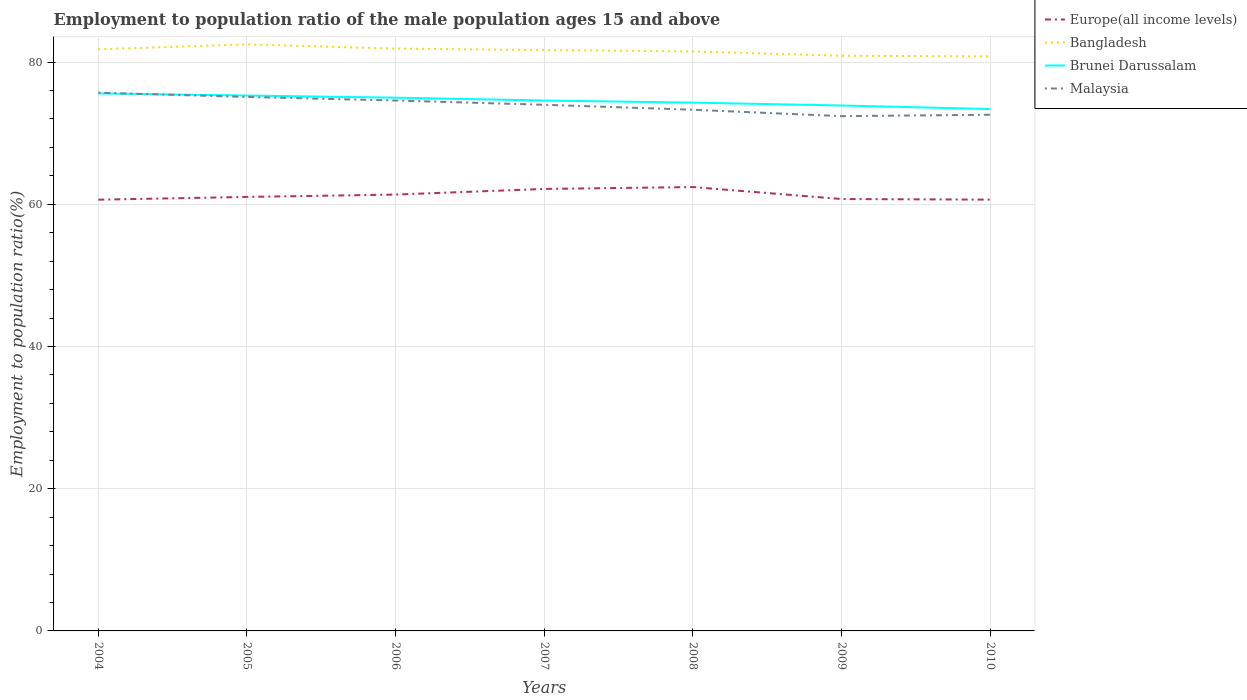Across all years, what is the maximum employment to population ratio in Bangladesh?
Give a very brief answer. 80.8. What is the total employment to population ratio in Malaysia in the graph?
Provide a succinct answer. 0.7. What is the difference between the highest and the second highest employment to population ratio in Malaysia?
Offer a very short reply. 3.3. Is the employment to population ratio in Brunei Darussalam strictly greater than the employment to population ratio in Bangladesh over the years?
Provide a short and direct response. Yes. How many years are there in the graph?
Provide a short and direct response. 7. Are the values on the major ticks of Y-axis written in scientific E-notation?
Offer a very short reply. No. Does the graph contain any zero values?
Provide a short and direct response. No. Does the graph contain grids?
Offer a terse response. Yes. Where does the legend appear in the graph?
Give a very brief answer. Top right. How many legend labels are there?
Your response must be concise. 4. How are the legend labels stacked?
Give a very brief answer. Vertical. What is the title of the graph?
Your response must be concise. Employment to population ratio of the male population ages 15 and above. What is the label or title of the X-axis?
Give a very brief answer. Years. What is the Employment to population ratio(%) of Europe(all income levels) in 2004?
Give a very brief answer. 60.65. What is the Employment to population ratio(%) in Bangladesh in 2004?
Ensure brevity in your answer.  81.8. What is the Employment to population ratio(%) in Brunei Darussalam in 2004?
Your response must be concise. 75.6. What is the Employment to population ratio(%) of Malaysia in 2004?
Offer a terse response. 75.7. What is the Employment to population ratio(%) of Europe(all income levels) in 2005?
Provide a short and direct response. 61.04. What is the Employment to population ratio(%) in Bangladesh in 2005?
Offer a very short reply. 82.5. What is the Employment to population ratio(%) of Brunei Darussalam in 2005?
Provide a short and direct response. 75.3. What is the Employment to population ratio(%) of Malaysia in 2005?
Offer a very short reply. 75.1. What is the Employment to population ratio(%) in Europe(all income levels) in 2006?
Your response must be concise. 61.37. What is the Employment to population ratio(%) of Bangladesh in 2006?
Ensure brevity in your answer.  81.9. What is the Employment to population ratio(%) in Malaysia in 2006?
Provide a short and direct response. 74.6. What is the Employment to population ratio(%) in Europe(all income levels) in 2007?
Ensure brevity in your answer.  62.16. What is the Employment to population ratio(%) of Bangladesh in 2007?
Your response must be concise. 81.7. What is the Employment to population ratio(%) in Brunei Darussalam in 2007?
Your response must be concise. 74.6. What is the Employment to population ratio(%) of Malaysia in 2007?
Keep it short and to the point. 74. What is the Employment to population ratio(%) in Europe(all income levels) in 2008?
Make the answer very short. 62.43. What is the Employment to population ratio(%) in Bangladesh in 2008?
Your answer should be compact. 81.5. What is the Employment to population ratio(%) of Brunei Darussalam in 2008?
Provide a succinct answer. 74.3. What is the Employment to population ratio(%) in Malaysia in 2008?
Offer a terse response. 73.3. What is the Employment to population ratio(%) in Europe(all income levels) in 2009?
Provide a short and direct response. 60.74. What is the Employment to population ratio(%) in Bangladesh in 2009?
Offer a terse response. 80.9. What is the Employment to population ratio(%) of Brunei Darussalam in 2009?
Ensure brevity in your answer.  73.9. What is the Employment to population ratio(%) of Malaysia in 2009?
Keep it short and to the point. 72.4. What is the Employment to population ratio(%) in Europe(all income levels) in 2010?
Provide a short and direct response. 60.66. What is the Employment to population ratio(%) of Bangladesh in 2010?
Your response must be concise. 80.8. What is the Employment to population ratio(%) in Brunei Darussalam in 2010?
Offer a terse response. 73.4. What is the Employment to population ratio(%) in Malaysia in 2010?
Keep it short and to the point. 72.6. Across all years, what is the maximum Employment to population ratio(%) in Europe(all income levels)?
Offer a very short reply. 62.43. Across all years, what is the maximum Employment to population ratio(%) of Bangladesh?
Your answer should be compact. 82.5. Across all years, what is the maximum Employment to population ratio(%) of Brunei Darussalam?
Provide a succinct answer. 75.6. Across all years, what is the maximum Employment to population ratio(%) of Malaysia?
Give a very brief answer. 75.7. Across all years, what is the minimum Employment to population ratio(%) of Europe(all income levels)?
Give a very brief answer. 60.65. Across all years, what is the minimum Employment to population ratio(%) in Bangladesh?
Give a very brief answer. 80.8. Across all years, what is the minimum Employment to population ratio(%) in Brunei Darussalam?
Provide a short and direct response. 73.4. Across all years, what is the minimum Employment to population ratio(%) of Malaysia?
Give a very brief answer. 72.4. What is the total Employment to population ratio(%) of Europe(all income levels) in the graph?
Keep it short and to the point. 429.06. What is the total Employment to population ratio(%) of Bangladesh in the graph?
Provide a short and direct response. 571.1. What is the total Employment to population ratio(%) in Brunei Darussalam in the graph?
Offer a terse response. 522.1. What is the total Employment to population ratio(%) of Malaysia in the graph?
Make the answer very short. 517.7. What is the difference between the Employment to population ratio(%) in Europe(all income levels) in 2004 and that in 2005?
Your answer should be very brief. -0.39. What is the difference between the Employment to population ratio(%) of Brunei Darussalam in 2004 and that in 2005?
Make the answer very short. 0.3. What is the difference between the Employment to population ratio(%) in Malaysia in 2004 and that in 2005?
Keep it short and to the point. 0.6. What is the difference between the Employment to population ratio(%) in Europe(all income levels) in 2004 and that in 2006?
Provide a succinct answer. -0.72. What is the difference between the Employment to population ratio(%) in Bangladesh in 2004 and that in 2006?
Keep it short and to the point. -0.1. What is the difference between the Employment to population ratio(%) in Brunei Darussalam in 2004 and that in 2006?
Offer a very short reply. 0.6. What is the difference between the Employment to population ratio(%) in Europe(all income levels) in 2004 and that in 2007?
Provide a succinct answer. -1.51. What is the difference between the Employment to population ratio(%) in Bangladesh in 2004 and that in 2007?
Your answer should be very brief. 0.1. What is the difference between the Employment to population ratio(%) of Europe(all income levels) in 2004 and that in 2008?
Ensure brevity in your answer.  -1.78. What is the difference between the Employment to population ratio(%) of Malaysia in 2004 and that in 2008?
Your answer should be compact. 2.4. What is the difference between the Employment to population ratio(%) in Europe(all income levels) in 2004 and that in 2009?
Offer a very short reply. -0.09. What is the difference between the Employment to population ratio(%) in Bangladesh in 2004 and that in 2009?
Your answer should be very brief. 0.9. What is the difference between the Employment to population ratio(%) in Europe(all income levels) in 2004 and that in 2010?
Ensure brevity in your answer.  -0.01. What is the difference between the Employment to population ratio(%) in Bangladesh in 2004 and that in 2010?
Ensure brevity in your answer.  1. What is the difference between the Employment to population ratio(%) of Brunei Darussalam in 2004 and that in 2010?
Make the answer very short. 2.2. What is the difference between the Employment to population ratio(%) of Malaysia in 2004 and that in 2010?
Keep it short and to the point. 3.1. What is the difference between the Employment to population ratio(%) in Europe(all income levels) in 2005 and that in 2006?
Ensure brevity in your answer.  -0.33. What is the difference between the Employment to population ratio(%) of Bangladesh in 2005 and that in 2006?
Make the answer very short. 0.6. What is the difference between the Employment to population ratio(%) of Europe(all income levels) in 2005 and that in 2007?
Your response must be concise. -1.13. What is the difference between the Employment to population ratio(%) of Europe(all income levels) in 2005 and that in 2008?
Ensure brevity in your answer.  -1.39. What is the difference between the Employment to population ratio(%) of Malaysia in 2005 and that in 2008?
Keep it short and to the point. 1.8. What is the difference between the Employment to population ratio(%) of Europe(all income levels) in 2005 and that in 2009?
Ensure brevity in your answer.  0.29. What is the difference between the Employment to population ratio(%) in Bangladesh in 2005 and that in 2009?
Give a very brief answer. 1.6. What is the difference between the Employment to population ratio(%) in Brunei Darussalam in 2005 and that in 2009?
Ensure brevity in your answer.  1.4. What is the difference between the Employment to population ratio(%) of Malaysia in 2005 and that in 2009?
Ensure brevity in your answer.  2.7. What is the difference between the Employment to population ratio(%) of Europe(all income levels) in 2005 and that in 2010?
Give a very brief answer. 0.38. What is the difference between the Employment to population ratio(%) of Brunei Darussalam in 2005 and that in 2010?
Your answer should be very brief. 1.9. What is the difference between the Employment to population ratio(%) in Malaysia in 2005 and that in 2010?
Keep it short and to the point. 2.5. What is the difference between the Employment to population ratio(%) in Europe(all income levels) in 2006 and that in 2007?
Your answer should be very brief. -0.79. What is the difference between the Employment to population ratio(%) in Brunei Darussalam in 2006 and that in 2007?
Provide a short and direct response. 0.4. What is the difference between the Employment to population ratio(%) of Malaysia in 2006 and that in 2007?
Offer a very short reply. 0.6. What is the difference between the Employment to population ratio(%) of Europe(all income levels) in 2006 and that in 2008?
Your answer should be very brief. -1.06. What is the difference between the Employment to population ratio(%) in Bangladesh in 2006 and that in 2008?
Give a very brief answer. 0.4. What is the difference between the Employment to population ratio(%) in Malaysia in 2006 and that in 2008?
Ensure brevity in your answer.  1.3. What is the difference between the Employment to population ratio(%) of Europe(all income levels) in 2006 and that in 2009?
Give a very brief answer. 0.63. What is the difference between the Employment to population ratio(%) of Europe(all income levels) in 2006 and that in 2010?
Offer a terse response. 0.71. What is the difference between the Employment to population ratio(%) in Brunei Darussalam in 2006 and that in 2010?
Your answer should be very brief. 1.6. What is the difference between the Employment to population ratio(%) of Malaysia in 2006 and that in 2010?
Offer a very short reply. 2. What is the difference between the Employment to population ratio(%) of Europe(all income levels) in 2007 and that in 2008?
Offer a terse response. -0.26. What is the difference between the Employment to population ratio(%) of Bangladesh in 2007 and that in 2008?
Give a very brief answer. 0.2. What is the difference between the Employment to population ratio(%) of Brunei Darussalam in 2007 and that in 2008?
Make the answer very short. 0.3. What is the difference between the Employment to population ratio(%) of Europe(all income levels) in 2007 and that in 2009?
Make the answer very short. 1.42. What is the difference between the Employment to population ratio(%) in Brunei Darussalam in 2007 and that in 2009?
Your answer should be compact. 0.7. What is the difference between the Employment to population ratio(%) in Malaysia in 2007 and that in 2009?
Your answer should be very brief. 1.6. What is the difference between the Employment to population ratio(%) of Europe(all income levels) in 2007 and that in 2010?
Keep it short and to the point. 1.5. What is the difference between the Employment to population ratio(%) in Brunei Darussalam in 2007 and that in 2010?
Your answer should be compact. 1.2. What is the difference between the Employment to population ratio(%) of Malaysia in 2007 and that in 2010?
Offer a very short reply. 1.4. What is the difference between the Employment to population ratio(%) of Europe(all income levels) in 2008 and that in 2009?
Keep it short and to the point. 1.69. What is the difference between the Employment to population ratio(%) of Malaysia in 2008 and that in 2009?
Keep it short and to the point. 0.9. What is the difference between the Employment to population ratio(%) in Europe(all income levels) in 2008 and that in 2010?
Provide a succinct answer. 1.77. What is the difference between the Employment to population ratio(%) of Bangladesh in 2008 and that in 2010?
Your response must be concise. 0.7. What is the difference between the Employment to population ratio(%) in Brunei Darussalam in 2008 and that in 2010?
Make the answer very short. 0.9. What is the difference between the Employment to population ratio(%) in Malaysia in 2008 and that in 2010?
Ensure brevity in your answer.  0.7. What is the difference between the Employment to population ratio(%) of Europe(all income levels) in 2009 and that in 2010?
Your answer should be very brief. 0.08. What is the difference between the Employment to population ratio(%) in Bangladesh in 2009 and that in 2010?
Your response must be concise. 0.1. What is the difference between the Employment to population ratio(%) of Brunei Darussalam in 2009 and that in 2010?
Your response must be concise. 0.5. What is the difference between the Employment to population ratio(%) in Malaysia in 2009 and that in 2010?
Your answer should be very brief. -0.2. What is the difference between the Employment to population ratio(%) of Europe(all income levels) in 2004 and the Employment to population ratio(%) of Bangladesh in 2005?
Offer a very short reply. -21.85. What is the difference between the Employment to population ratio(%) of Europe(all income levels) in 2004 and the Employment to population ratio(%) of Brunei Darussalam in 2005?
Give a very brief answer. -14.65. What is the difference between the Employment to population ratio(%) in Europe(all income levels) in 2004 and the Employment to population ratio(%) in Malaysia in 2005?
Your response must be concise. -14.45. What is the difference between the Employment to population ratio(%) in Bangladesh in 2004 and the Employment to population ratio(%) in Brunei Darussalam in 2005?
Offer a terse response. 6.5. What is the difference between the Employment to population ratio(%) of Europe(all income levels) in 2004 and the Employment to population ratio(%) of Bangladesh in 2006?
Make the answer very short. -21.25. What is the difference between the Employment to population ratio(%) in Europe(all income levels) in 2004 and the Employment to population ratio(%) in Brunei Darussalam in 2006?
Ensure brevity in your answer.  -14.35. What is the difference between the Employment to population ratio(%) of Europe(all income levels) in 2004 and the Employment to population ratio(%) of Malaysia in 2006?
Your answer should be very brief. -13.95. What is the difference between the Employment to population ratio(%) of Brunei Darussalam in 2004 and the Employment to population ratio(%) of Malaysia in 2006?
Make the answer very short. 1. What is the difference between the Employment to population ratio(%) in Europe(all income levels) in 2004 and the Employment to population ratio(%) in Bangladesh in 2007?
Your response must be concise. -21.05. What is the difference between the Employment to population ratio(%) in Europe(all income levels) in 2004 and the Employment to population ratio(%) in Brunei Darussalam in 2007?
Ensure brevity in your answer.  -13.95. What is the difference between the Employment to population ratio(%) in Europe(all income levels) in 2004 and the Employment to population ratio(%) in Malaysia in 2007?
Your answer should be very brief. -13.35. What is the difference between the Employment to population ratio(%) of Bangladesh in 2004 and the Employment to population ratio(%) of Malaysia in 2007?
Your answer should be very brief. 7.8. What is the difference between the Employment to population ratio(%) in Europe(all income levels) in 2004 and the Employment to population ratio(%) in Bangladesh in 2008?
Your answer should be compact. -20.85. What is the difference between the Employment to population ratio(%) in Europe(all income levels) in 2004 and the Employment to population ratio(%) in Brunei Darussalam in 2008?
Give a very brief answer. -13.65. What is the difference between the Employment to population ratio(%) in Europe(all income levels) in 2004 and the Employment to population ratio(%) in Malaysia in 2008?
Give a very brief answer. -12.65. What is the difference between the Employment to population ratio(%) in Bangladesh in 2004 and the Employment to population ratio(%) in Malaysia in 2008?
Your response must be concise. 8.5. What is the difference between the Employment to population ratio(%) of Brunei Darussalam in 2004 and the Employment to population ratio(%) of Malaysia in 2008?
Give a very brief answer. 2.3. What is the difference between the Employment to population ratio(%) in Europe(all income levels) in 2004 and the Employment to population ratio(%) in Bangladesh in 2009?
Your response must be concise. -20.25. What is the difference between the Employment to population ratio(%) of Europe(all income levels) in 2004 and the Employment to population ratio(%) of Brunei Darussalam in 2009?
Make the answer very short. -13.25. What is the difference between the Employment to population ratio(%) in Europe(all income levels) in 2004 and the Employment to population ratio(%) in Malaysia in 2009?
Offer a very short reply. -11.75. What is the difference between the Employment to population ratio(%) of Bangladesh in 2004 and the Employment to population ratio(%) of Brunei Darussalam in 2009?
Your answer should be compact. 7.9. What is the difference between the Employment to population ratio(%) of Bangladesh in 2004 and the Employment to population ratio(%) of Malaysia in 2009?
Make the answer very short. 9.4. What is the difference between the Employment to population ratio(%) in Europe(all income levels) in 2004 and the Employment to population ratio(%) in Bangladesh in 2010?
Your answer should be compact. -20.15. What is the difference between the Employment to population ratio(%) of Europe(all income levels) in 2004 and the Employment to population ratio(%) of Brunei Darussalam in 2010?
Provide a short and direct response. -12.75. What is the difference between the Employment to population ratio(%) of Europe(all income levels) in 2004 and the Employment to population ratio(%) of Malaysia in 2010?
Your answer should be compact. -11.95. What is the difference between the Employment to population ratio(%) of Brunei Darussalam in 2004 and the Employment to population ratio(%) of Malaysia in 2010?
Make the answer very short. 3. What is the difference between the Employment to population ratio(%) in Europe(all income levels) in 2005 and the Employment to population ratio(%) in Bangladesh in 2006?
Keep it short and to the point. -20.86. What is the difference between the Employment to population ratio(%) in Europe(all income levels) in 2005 and the Employment to population ratio(%) in Brunei Darussalam in 2006?
Your answer should be very brief. -13.96. What is the difference between the Employment to population ratio(%) in Europe(all income levels) in 2005 and the Employment to population ratio(%) in Malaysia in 2006?
Offer a terse response. -13.56. What is the difference between the Employment to population ratio(%) in Bangladesh in 2005 and the Employment to population ratio(%) in Malaysia in 2006?
Provide a short and direct response. 7.9. What is the difference between the Employment to population ratio(%) in Brunei Darussalam in 2005 and the Employment to population ratio(%) in Malaysia in 2006?
Ensure brevity in your answer.  0.7. What is the difference between the Employment to population ratio(%) in Europe(all income levels) in 2005 and the Employment to population ratio(%) in Bangladesh in 2007?
Keep it short and to the point. -20.66. What is the difference between the Employment to population ratio(%) in Europe(all income levels) in 2005 and the Employment to population ratio(%) in Brunei Darussalam in 2007?
Your response must be concise. -13.56. What is the difference between the Employment to population ratio(%) in Europe(all income levels) in 2005 and the Employment to population ratio(%) in Malaysia in 2007?
Offer a terse response. -12.96. What is the difference between the Employment to population ratio(%) in Brunei Darussalam in 2005 and the Employment to population ratio(%) in Malaysia in 2007?
Offer a terse response. 1.3. What is the difference between the Employment to population ratio(%) of Europe(all income levels) in 2005 and the Employment to population ratio(%) of Bangladesh in 2008?
Your answer should be compact. -20.46. What is the difference between the Employment to population ratio(%) of Europe(all income levels) in 2005 and the Employment to population ratio(%) of Brunei Darussalam in 2008?
Give a very brief answer. -13.26. What is the difference between the Employment to population ratio(%) in Europe(all income levels) in 2005 and the Employment to population ratio(%) in Malaysia in 2008?
Your response must be concise. -12.26. What is the difference between the Employment to population ratio(%) in Bangladesh in 2005 and the Employment to population ratio(%) in Malaysia in 2008?
Your answer should be compact. 9.2. What is the difference between the Employment to population ratio(%) in Brunei Darussalam in 2005 and the Employment to population ratio(%) in Malaysia in 2008?
Ensure brevity in your answer.  2. What is the difference between the Employment to population ratio(%) in Europe(all income levels) in 2005 and the Employment to population ratio(%) in Bangladesh in 2009?
Your answer should be compact. -19.86. What is the difference between the Employment to population ratio(%) in Europe(all income levels) in 2005 and the Employment to population ratio(%) in Brunei Darussalam in 2009?
Give a very brief answer. -12.86. What is the difference between the Employment to population ratio(%) in Europe(all income levels) in 2005 and the Employment to population ratio(%) in Malaysia in 2009?
Provide a short and direct response. -11.36. What is the difference between the Employment to population ratio(%) in Bangladesh in 2005 and the Employment to population ratio(%) in Brunei Darussalam in 2009?
Your answer should be compact. 8.6. What is the difference between the Employment to population ratio(%) of Bangladesh in 2005 and the Employment to population ratio(%) of Malaysia in 2009?
Your response must be concise. 10.1. What is the difference between the Employment to population ratio(%) in Brunei Darussalam in 2005 and the Employment to population ratio(%) in Malaysia in 2009?
Your answer should be compact. 2.9. What is the difference between the Employment to population ratio(%) of Europe(all income levels) in 2005 and the Employment to population ratio(%) of Bangladesh in 2010?
Make the answer very short. -19.76. What is the difference between the Employment to population ratio(%) in Europe(all income levels) in 2005 and the Employment to population ratio(%) in Brunei Darussalam in 2010?
Keep it short and to the point. -12.36. What is the difference between the Employment to population ratio(%) in Europe(all income levels) in 2005 and the Employment to population ratio(%) in Malaysia in 2010?
Your answer should be compact. -11.56. What is the difference between the Employment to population ratio(%) in Bangladesh in 2005 and the Employment to population ratio(%) in Malaysia in 2010?
Ensure brevity in your answer.  9.9. What is the difference between the Employment to population ratio(%) of Europe(all income levels) in 2006 and the Employment to population ratio(%) of Bangladesh in 2007?
Make the answer very short. -20.33. What is the difference between the Employment to population ratio(%) of Europe(all income levels) in 2006 and the Employment to population ratio(%) of Brunei Darussalam in 2007?
Give a very brief answer. -13.23. What is the difference between the Employment to population ratio(%) of Europe(all income levels) in 2006 and the Employment to population ratio(%) of Malaysia in 2007?
Your answer should be compact. -12.63. What is the difference between the Employment to population ratio(%) in Bangladesh in 2006 and the Employment to population ratio(%) in Brunei Darussalam in 2007?
Ensure brevity in your answer.  7.3. What is the difference between the Employment to population ratio(%) in Bangladesh in 2006 and the Employment to population ratio(%) in Malaysia in 2007?
Your answer should be compact. 7.9. What is the difference between the Employment to population ratio(%) of Europe(all income levels) in 2006 and the Employment to population ratio(%) of Bangladesh in 2008?
Your response must be concise. -20.13. What is the difference between the Employment to population ratio(%) in Europe(all income levels) in 2006 and the Employment to population ratio(%) in Brunei Darussalam in 2008?
Your answer should be very brief. -12.93. What is the difference between the Employment to population ratio(%) in Europe(all income levels) in 2006 and the Employment to population ratio(%) in Malaysia in 2008?
Give a very brief answer. -11.93. What is the difference between the Employment to population ratio(%) of Bangladesh in 2006 and the Employment to population ratio(%) of Malaysia in 2008?
Offer a terse response. 8.6. What is the difference between the Employment to population ratio(%) in Europe(all income levels) in 2006 and the Employment to population ratio(%) in Bangladesh in 2009?
Keep it short and to the point. -19.53. What is the difference between the Employment to population ratio(%) of Europe(all income levels) in 2006 and the Employment to population ratio(%) of Brunei Darussalam in 2009?
Keep it short and to the point. -12.53. What is the difference between the Employment to population ratio(%) in Europe(all income levels) in 2006 and the Employment to population ratio(%) in Malaysia in 2009?
Provide a short and direct response. -11.03. What is the difference between the Employment to population ratio(%) of Bangladesh in 2006 and the Employment to population ratio(%) of Malaysia in 2009?
Give a very brief answer. 9.5. What is the difference between the Employment to population ratio(%) in Brunei Darussalam in 2006 and the Employment to population ratio(%) in Malaysia in 2009?
Provide a succinct answer. 2.6. What is the difference between the Employment to population ratio(%) of Europe(all income levels) in 2006 and the Employment to population ratio(%) of Bangladesh in 2010?
Your answer should be compact. -19.43. What is the difference between the Employment to population ratio(%) in Europe(all income levels) in 2006 and the Employment to population ratio(%) in Brunei Darussalam in 2010?
Your response must be concise. -12.03. What is the difference between the Employment to population ratio(%) in Europe(all income levels) in 2006 and the Employment to population ratio(%) in Malaysia in 2010?
Provide a short and direct response. -11.23. What is the difference between the Employment to population ratio(%) in Bangladesh in 2006 and the Employment to population ratio(%) in Brunei Darussalam in 2010?
Offer a very short reply. 8.5. What is the difference between the Employment to population ratio(%) in Brunei Darussalam in 2006 and the Employment to population ratio(%) in Malaysia in 2010?
Keep it short and to the point. 2.4. What is the difference between the Employment to population ratio(%) in Europe(all income levels) in 2007 and the Employment to population ratio(%) in Bangladesh in 2008?
Offer a very short reply. -19.34. What is the difference between the Employment to population ratio(%) in Europe(all income levels) in 2007 and the Employment to population ratio(%) in Brunei Darussalam in 2008?
Ensure brevity in your answer.  -12.14. What is the difference between the Employment to population ratio(%) of Europe(all income levels) in 2007 and the Employment to population ratio(%) of Malaysia in 2008?
Provide a short and direct response. -11.14. What is the difference between the Employment to population ratio(%) of Europe(all income levels) in 2007 and the Employment to population ratio(%) of Bangladesh in 2009?
Your answer should be very brief. -18.74. What is the difference between the Employment to population ratio(%) of Europe(all income levels) in 2007 and the Employment to population ratio(%) of Brunei Darussalam in 2009?
Provide a succinct answer. -11.74. What is the difference between the Employment to population ratio(%) of Europe(all income levels) in 2007 and the Employment to population ratio(%) of Malaysia in 2009?
Provide a succinct answer. -10.24. What is the difference between the Employment to population ratio(%) of Bangladesh in 2007 and the Employment to population ratio(%) of Malaysia in 2009?
Offer a very short reply. 9.3. What is the difference between the Employment to population ratio(%) of Europe(all income levels) in 2007 and the Employment to population ratio(%) of Bangladesh in 2010?
Keep it short and to the point. -18.64. What is the difference between the Employment to population ratio(%) in Europe(all income levels) in 2007 and the Employment to population ratio(%) in Brunei Darussalam in 2010?
Give a very brief answer. -11.24. What is the difference between the Employment to population ratio(%) in Europe(all income levels) in 2007 and the Employment to population ratio(%) in Malaysia in 2010?
Provide a succinct answer. -10.44. What is the difference between the Employment to population ratio(%) of Bangladesh in 2007 and the Employment to population ratio(%) of Brunei Darussalam in 2010?
Give a very brief answer. 8.3. What is the difference between the Employment to population ratio(%) of Brunei Darussalam in 2007 and the Employment to population ratio(%) of Malaysia in 2010?
Keep it short and to the point. 2. What is the difference between the Employment to population ratio(%) in Europe(all income levels) in 2008 and the Employment to population ratio(%) in Bangladesh in 2009?
Offer a very short reply. -18.47. What is the difference between the Employment to population ratio(%) in Europe(all income levels) in 2008 and the Employment to population ratio(%) in Brunei Darussalam in 2009?
Provide a succinct answer. -11.47. What is the difference between the Employment to population ratio(%) in Europe(all income levels) in 2008 and the Employment to population ratio(%) in Malaysia in 2009?
Ensure brevity in your answer.  -9.97. What is the difference between the Employment to population ratio(%) of Bangladesh in 2008 and the Employment to population ratio(%) of Brunei Darussalam in 2009?
Your answer should be very brief. 7.6. What is the difference between the Employment to population ratio(%) of Bangladesh in 2008 and the Employment to population ratio(%) of Malaysia in 2009?
Give a very brief answer. 9.1. What is the difference between the Employment to population ratio(%) in Brunei Darussalam in 2008 and the Employment to population ratio(%) in Malaysia in 2009?
Your response must be concise. 1.9. What is the difference between the Employment to population ratio(%) of Europe(all income levels) in 2008 and the Employment to population ratio(%) of Bangladesh in 2010?
Your response must be concise. -18.37. What is the difference between the Employment to population ratio(%) of Europe(all income levels) in 2008 and the Employment to population ratio(%) of Brunei Darussalam in 2010?
Provide a short and direct response. -10.97. What is the difference between the Employment to population ratio(%) of Europe(all income levels) in 2008 and the Employment to population ratio(%) of Malaysia in 2010?
Keep it short and to the point. -10.17. What is the difference between the Employment to population ratio(%) in Bangladesh in 2008 and the Employment to population ratio(%) in Brunei Darussalam in 2010?
Keep it short and to the point. 8.1. What is the difference between the Employment to population ratio(%) of Europe(all income levels) in 2009 and the Employment to population ratio(%) of Bangladesh in 2010?
Your answer should be very brief. -20.06. What is the difference between the Employment to population ratio(%) in Europe(all income levels) in 2009 and the Employment to population ratio(%) in Brunei Darussalam in 2010?
Give a very brief answer. -12.66. What is the difference between the Employment to population ratio(%) of Europe(all income levels) in 2009 and the Employment to population ratio(%) of Malaysia in 2010?
Your response must be concise. -11.86. What is the difference between the Employment to population ratio(%) of Bangladesh in 2009 and the Employment to population ratio(%) of Brunei Darussalam in 2010?
Your answer should be compact. 7.5. What is the difference between the Employment to population ratio(%) of Bangladesh in 2009 and the Employment to population ratio(%) of Malaysia in 2010?
Your answer should be compact. 8.3. What is the average Employment to population ratio(%) in Europe(all income levels) per year?
Your answer should be very brief. 61.29. What is the average Employment to population ratio(%) in Bangladesh per year?
Your answer should be compact. 81.59. What is the average Employment to population ratio(%) in Brunei Darussalam per year?
Offer a very short reply. 74.59. What is the average Employment to population ratio(%) in Malaysia per year?
Keep it short and to the point. 73.96. In the year 2004, what is the difference between the Employment to population ratio(%) in Europe(all income levels) and Employment to population ratio(%) in Bangladesh?
Offer a very short reply. -21.15. In the year 2004, what is the difference between the Employment to population ratio(%) in Europe(all income levels) and Employment to population ratio(%) in Brunei Darussalam?
Ensure brevity in your answer.  -14.95. In the year 2004, what is the difference between the Employment to population ratio(%) of Europe(all income levels) and Employment to population ratio(%) of Malaysia?
Offer a very short reply. -15.05. In the year 2004, what is the difference between the Employment to population ratio(%) in Bangladesh and Employment to population ratio(%) in Brunei Darussalam?
Give a very brief answer. 6.2. In the year 2004, what is the difference between the Employment to population ratio(%) in Bangladesh and Employment to population ratio(%) in Malaysia?
Make the answer very short. 6.1. In the year 2005, what is the difference between the Employment to population ratio(%) in Europe(all income levels) and Employment to population ratio(%) in Bangladesh?
Your answer should be very brief. -21.46. In the year 2005, what is the difference between the Employment to population ratio(%) in Europe(all income levels) and Employment to population ratio(%) in Brunei Darussalam?
Offer a very short reply. -14.26. In the year 2005, what is the difference between the Employment to population ratio(%) of Europe(all income levels) and Employment to population ratio(%) of Malaysia?
Your answer should be compact. -14.06. In the year 2005, what is the difference between the Employment to population ratio(%) in Bangladesh and Employment to population ratio(%) in Malaysia?
Give a very brief answer. 7.4. In the year 2006, what is the difference between the Employment to population ratio(%) in Europe(all income levels) and Employment to population ratio(%) in Bangladesh?
Offer a terse response. -20.53. In the year 2006, what is the difference between the Employment to population ratio(%) in Europe(all income levels) and Employment to population ratio(%) in Brunei Darussalam?
Provide a short and direct response. -13.63. In the year 2006, what is the difference between the Employment to population ratio(%) in Europe(all income levels) and Employment to population ratio(%) in Malaysia?
Offer a terse response. -13.23. In the year 2006, what is the difference between the Employment to population ratio(%) of Bangladesh and Employment to population ratio(%) of Malaysia?
Your answer should be very brief. 7.3. In the year 2007, what is the difference between the Employment to population ratio(%) of Europe(all income levels) and Employment to population ratio(%) of Bangladesh?
Ensure brevity in your answer.  -19.54. In the year 2007, what is the difference between the Employment to population ratio(%) of Europe(all income levels) and Employment to population ratio(%) of Brunei Darussalam?
Ensure brevity in your answer.  -12.44. In the year 2007, what is the difference between the Employment to population ratio(%) in Europe(all income levels) and Employment to population ratio(%) in Malaysia?
Keep it short and to the point. -11.84. In the year 2007, what is the difference between the Employment to population ratio(%) in Bangladesh and Employment to population ratio(%) in Brunei Darussalam?
Your answer should be compact. 7.1. In the year 2007, what is the difference between the Employment to population ratio(%) in Brunei Darussalam and Employment to population ratio(%) in Malaysia?
Your answer should be compact. 0.6. In the year 2008, what is the difference between the Employment to population ratio(%) in Europe(all income levels) and Employment to population ratio(%) in Bangladesh?
Give a very brief answer. -19.07. In the year 2008, what is the difference between the Employment to population ratio(%) in Europe(all income levels) and Employment to population ratio(%) in Brunei Darussalam?
Ensure brevity in your answer.  -11.87. In the year 2008, what is the difference between the Employment to population ratio(%) of Europe(all income levels) and Employment to population ratio(%) of Malaysia?
Your answer should be very brief. -10.87. In the year 2009, what is the difference between the Employment to population ratio(%) of Europe(all income levels) and Employment to population ratio(%) of Bangladesh?
Offer a terse response. -20.16. In the year 2009, what is the difference between the Employment to population ratio(%) of Europe(all income levels) and Employment to population ratio(%) of Brunei Darussalam?
Offer a very short reply. -13.16. In the year 2009, what is the difference between the Employment to population ratio(%) in Europe(all income levels) and Employment to population ratio(%) in Malaysia?
Make the answer very short. -11.66. In the year 2009, what is the difference between the Employment to population ratio(%) of Bangladesh and Employment to population ratio(%) of Brunei Darussalam?
Offer a terse response. 7. In the year 2010, what is the difference between the Employment to population ratio(%) in Europe(all income levels) and Employment to population ratio(%) in Bangladesh?
Your response must be concise. -20.14. In the year 2010, what is the difference between the Employment to population ratio(%) in Europe(all income levels) and Employment to population ratio(%) in Brunei Darussalam?
Your response must be concise. -12.74. In the year 2010, what is the difference between the Employment to population ratio(%) in Europe(all income levels) and Employment to population ratio(%) in Malaysia?
Offer a terse response. -11.94. In the year 2010, what is the difference between the Employment to population ratio(%) of Bangladesh and Employment to population ratio(%) of Brunei Darussalam?
Your answer should be compact. 7.4. In the year 2010, what is the difference between the Employment to population ratio(%) of Bangladesh and Employment to population ratio(%) of Malaysia?
Your answer should be very brief. 8.2. In the year 2010, what is the difference between the Employment to population ratio(%) of Brunei Darussalam and Employment to population ratio(%) of Malaysia?
Your answer should be compact. 0.8. What is the ratio of the Employment to population ratio(%) in Brunei Darussalam in 2004 to that in 2005?
Provide a short and direct response. 1. What is the ratio of the Employment to population ratio(%) in Europe(all income levels) in 2004 to that in 2006?
Make the answer very short. 0.99. What is the ratio of the Employment to population ratio(%) of Malaysia in 2004 to that in 2006?
Keep it short and to the point. 1.01. What is the ratio of the Employment to population ratio(%) in Europe(all income levels) in 2004 to that in 2007?
Your answer should be compact. 0.98. What is the ratio of the Employment to population ratio(%) of Bangladesh in 2004 to that in 2007?
Provide a succinct answer. 1. What is the ratio of the Employment to population ratio(%) in Brunei Darussalam in 2004 to that in 2007?
Ensure brevity in your answer.  1.01. What is the ratio of the Employment to population ratio(%) in Europe(all income levels) in 2004 to that in 2008?
Give a very brief answer. 0.97. What is the ratio of the Employment to population ratio(%) in Bangladesh in 2004 to that in 2008?
Your response must be concise. 1. What is the ratio of the Employment to population ratio(%) of Brunei Darussalam in 2004 to that in 2008?
Offer a terse response. 1.02. What is the ratio of the Employment to population ratio(%) of Malaysia in 2004 to that in 2008?
Keep it short and to the point. 1.03. What is the ratio of the Employment to population ratio(%) of Europe(all income levels) in 2004 to that in 2009?
Offer a terse response. 1. What is the ratio of the Employment to population ratio(%) in Bangladesh in 2004 to that in 2009?
Give a very brief answer. 1.01. What is the ratio of the Employment to population ratio(%) in Brunei Darussalam in 2004 to that in 2009?
Ensure brevity in your answer.  1.02. What is the ratio of the Employment to population ratio(%) of Malaysia in 2004 to that in 2009?
Offer a terse response. 1.05. What is the ratio of the Employment to population ratio(%) of Bangladesh in 2004 to that in 2010?
Your answer should be compact. 1.01. What is the ratio of the Employment to population ratio(%) in Malaysia in 2004 to that in 2010?
Keep it short and to the point. 1.04. What is the ratio of the Employment to population ratio(%) in Bangladesh in 2005 to that in 2006?
Your response must be concise. 1.01. What is the ratio of the Employment to population ratio(%) of Europe(all income levels) in 2005 to that in 2007?
Your answer should be compact. 0.98. What is the ratio of the Employment to population ratio(%) of Bangladesh in 2005 to that in 2007?
Your answer should be very brief. 1.01. What is the ratio of the Employment to population ratio(%) in Brunei Darussalam in 2005 to that in 2007?
Your answer should be very brief. 1.01. What is the ratio of the Employment to population ratio(%) of Malaysia in 2005 to that in 2007?
Provide a short and direct response. 1.01. What is the ratio of the Employment to population ratio(%) in Europe(all income levels) in 2005 to that in 2008?
Give a very brief answer. 0.98. What is the ratio of the Employment to population ratio(%) of Bangladesh in 2005 to that in 2008?
Your answer should be very brief. 1.01. What is the ratio of the Employment to population ratio(%) of Brunei Darussalam in 2005 to that in 2008?
Offer a very short reply. 1.01. What is the ratio of the Employment to population ratio(%) in Malaysia in 2005 to that in 2008?
Offer a very short reply. 1.02. What is the ratio of the Employment to population ratio(%) in Bangladesh in 2005 to that in 2009?
Offer a very short reply. 1.02. What is the ratio of the Employment to population ratio(%) in Brunei Darussalam in 2005 to that in 2009?
Your response must be concise. 1.02. What is the ratio of the Employment to population ratio(%) of Malaysia in 2005 to that in 2009?
Provide a short and direct response. 1.04. What is the ratio of the Employment to population ratio(%) in Europe(all income levels) in 2005 to that in 2010?
Ensure brevity in your answer.  1.01. What is the ratio of the Employment to population ratio(%) in Brunei Darussalam in 2005 to that in 2010?
Offer a very short reply. 1.03. What is the ratio of the Employment to population ratio(%) in Malaysia in 2005 to that in 2010?
Your answer should be very brief. 1.03. What is the ratio of the Employment to population ratio(%) in Europe(all income levels) in 2006 to that in 2007?
Your answer should be compact. 0.99. What is the ratio of the Employment to population ratio(%) of Brunei Darussalam in 2006 to that in 2007?
Keep it short and to the point. 1.01. What is the ratio of the Employment to population ratio(%) in Malaysia in 2006 to that in 2007?
Your answer should be very brief. 1.01. What is the ratio of the Employment to population ratio(%) of Europe(all income levels) in 2006 to that in 2008?
Keep it short and to the point. 0.98. What is the ratio of the Employment to population ratio(%) in Brunei Darussalam in 2006 to that in 2008?
Your answer should be very brief. 1.01. What is the ratio of the Employment to population ratio(%) of Malaysia in 2006 to that in 2008?
Ensure brevity in your answer.  1.02. What is the ratio of the Employment to population ratio(%) of Europe(all income levels) in 2006 to that in 2009?
Provide a succinct answer. 1.01. What is the ratio of the Employment to population ratio(%) of Bangladesh in 2006 to that in 2009?
Your response must be concise. 1.01. What is the ratio of the Employment to population ratio(%) of Brunei Darussalam in 2006 to that in 2009?
Offer a terse response. 1.01. What is the ratio of the Employment to population ratio(%) in Malaysia in 2006 to that in 2009?
Provide a short and direct response. 1.03. What is the ratio of the Employment to population ratio(%) of Europe(all income levels) in 2006 to that in 2010?
Your answer should be compact. 1.01. What is the ratio of the Employment to population ratio(%) of Bangladesh in 2006 to that in 2010?
Provide a short and direct response. 1.01. What is the ratio of the Employment to population ratio(%) in Brunei Darussalam in 2006 to that in 2010?
Provide a short and direct response. 1.02. What is the ratio of the Employment to population ratio(%) of Malaysia in 2006 to that in 2010?
Ensure brevity in your answer.  1.03. What is the ratio of the Employment to population ratio(%) of Brunei Darussalam in 2007 to that in 2008?
Keep it short and to the point. 1. What is the ratio of the Employment to population ratio(%) of Malaysia in 2007 to that in 2008?
Your response must be concise. 1.01. What is the ratio of the Employment to population ratio(%) in Europe(all income levels) in 2007 to that in 2009?
Give a very brief answer. 1.02. What is the ratio of the Employment to population ratio(%) of Bangladesh in 2007 to that in 2009?
Offer a terse response. 1.01. What is the ratio of the Employment to population ratio(%) of Brunei Darussalam in 2007 to that in 2009?
Provide a succinct answer. 1.01. What is the ratio of the Employment to population ratio(%) in Malaysia in 2007 to that in 2009?
Offer a terse response. 1.02. What is the ratio of the Employment to population ratio(%) of Europe(all income levels) in 2007 to that in 2010?
Provide a succinct answer. 1.02. What is the ratio of the Employment to population ratio(%) in Bangladesh in 2007 to that in 2010?
Provide a succinct answer. 1.01. What is the ratio of the Employment to population ratio(%) of Brunei Darussalam in 2007 to that in 2010?
Offer a terse response. 1.02. What is the ratio of the Employment to population ratio(%) in Malaysia in 2007 to that in 2010?
Your response must be concise. 1.02. What is the ratio of the Employment to population ratio(%) in Europe(all income levels) in 2008 to that in 2009?
Provide a succinct answer. 1.03. What is the ratio of the Employment to population ratio(%) in Bangladesh in 2008 to that in 2009?
Your answer should be compact. 1.01. What is the ratio of the Employment to population ratio(%) in Brunei Darussalam in 2008 to that in 2009?
Offer a terse response. 1.01. What is the ratio of the Employment to population ratio(%) in Malaysia in 2008 to that in 2009?
Offer a terse response. 1.01. What is the ratio of the Employment to population ratio(%) of Europe(all income levels) in 2008 to that in 2010?
Provide a short and direct response. 1.03. What is the ratio of the Employment to population ratio(%) in Bangladesh in 2008 to that in 2010?
Provide a short and direct response. 1.01. What is the ratio of the Employment to population ratio(%) in Brunei Darussalam in 2008 to that in 2010?
Your answer should be compact. 1.01. What is the ratio of the Employment to population ratio(%) in Malaysia in 2008 to that in 2010?
Make the answer very short. 1.01. What is the ratio of the Employment to population ratio(%) in Europe(all income levels) in 2009 to that in 2010?
Provide a short and direct response. 1. What is the ratio of the Employment to population ratio(%) in Bangladesh in 2009 to that in 2010?
Your answer should be very brief. 1. What is the ratio of the Employment to population ratio(%) of Brunei Darussalam in 2009 to that in 2010?
Ensure brevity in your answer.  1.01. What is the difference between the highest and the second highest Employment to population ratio(%) of Europe(all income levels)?
Offer a terse response. 0.26. What is the difference between the highest and the second highest Employment to population ratio(%) of Bangladesh?
Your answer should be compact. 0.6. What is the difference between the highest and the second highest Employment to population ratio(%) of Malaysia?
Provide a succinct answer. 0.6. What is the difference between the highest and the lowest Employment to population ratio(%) in Europe(all income levels)?
Offer a terse response. 1.78. What is the difference between the highest and the lowest Employment to population ratio(%) in Bangladesh?
Your answer should be compact. 1.7. What is the difference between the highest and the lowest Employment to population ratio(%) of Brunei Darussalam?
Give a very brief answer. 2.2. 